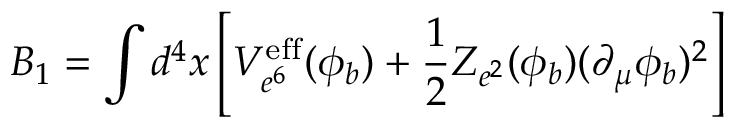Convert formula to latex. <formula><loc_0><loc_0><loc_500><loc_500>B _ { 1 } = \int d ^ { 4 } x \left [ V _ { e ^ { 6 } } ^ { e f f } ( \phi _ { b } ) + \frac { 1 } { 2 } Z _ { e ^ { 2 } } ( \phi _ { b } ) ( \partial _ { \mu } \phi _ { b } ) ^ { 2 } \right ]</formula> 